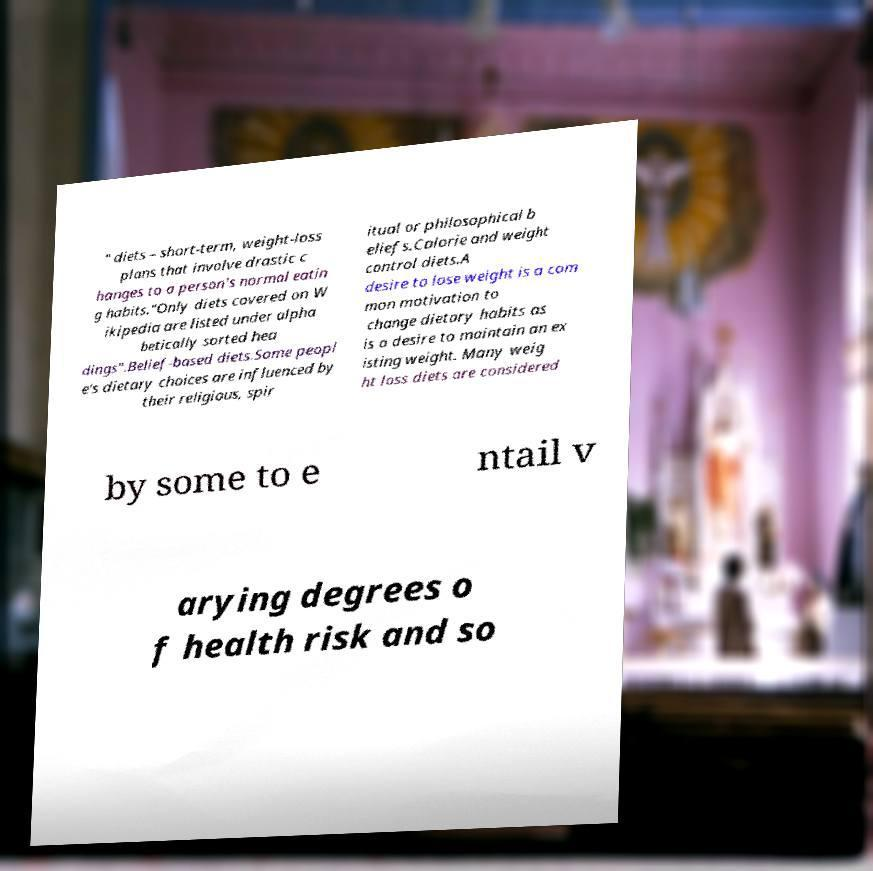Please read and relay the text visible in this image. What does it say? " diets – short-term, weight-loss plans that involve drastic c hanges to a person's normal eatin g habits."Only diets covered on W ikipedia are listed under alpha betically sorted hea dings".Belief-based diets.Some peopl e's dietary choices are influenced by their religious, spir itual or philosophical b eliefs.Calorie and weight control diets.A desire to lose weight is a com mon motivation to change dietary habits as is a desire to maintain an ex isting weight. Many weig ht loss diets are considered by some to e ntail v arying degrees o f health risk and so 